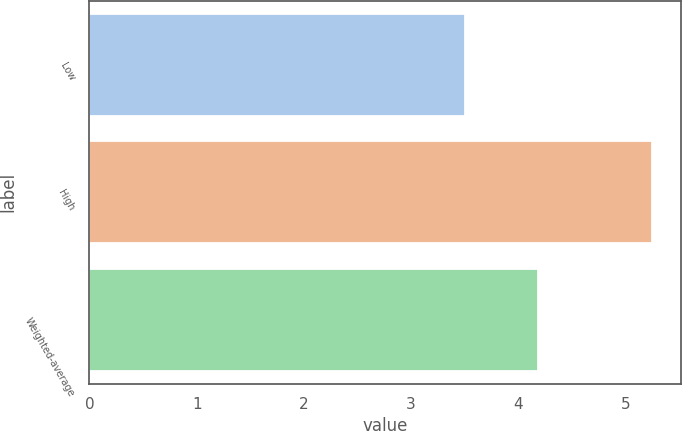Convert chart to OTSL. <chart><loc_0><loc_0><loc_500><loc_500><bar_chart><fcel>Low<fcel>High<fcel>Weighted-average<nl><fcel>3.5<fcel>5.25<fcel>4.18<nl></chart> 